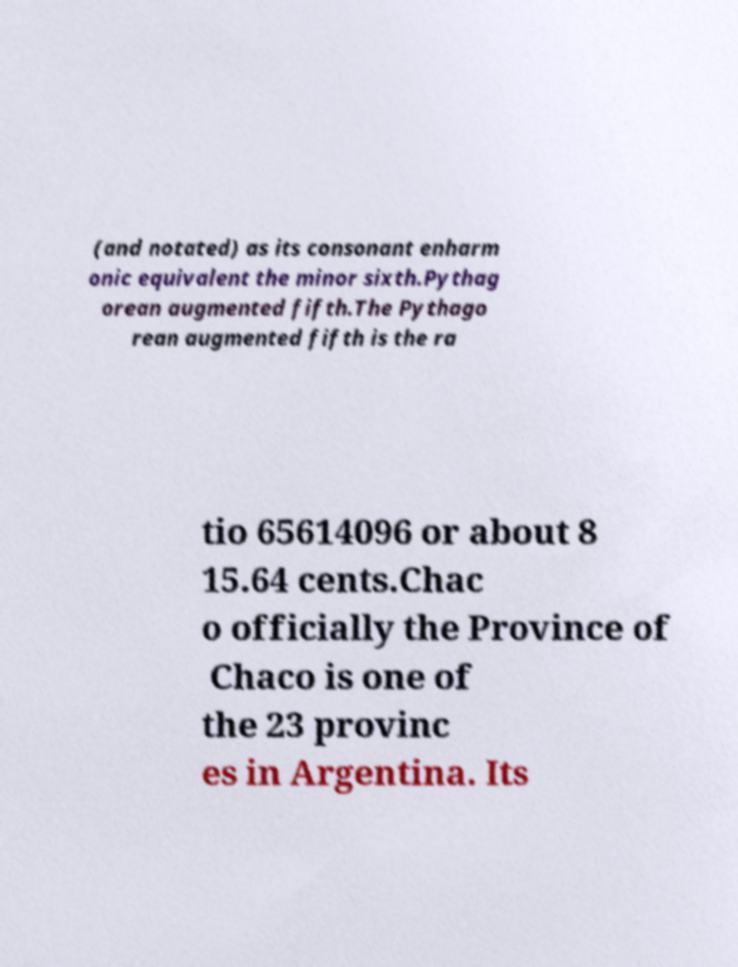Could you assist in decoding the text presented in this image and type it out clearly? (and notated) as its consonant enharm onic equivalent the minor sixth.Pythag orean augmented fifth.The Pythago rean augmented fifth is the ra tio 65614096 or about 8 15.64 cents.Chac o officially the Province of Chaco is one of the 23 provinc es in Argentina. Its 